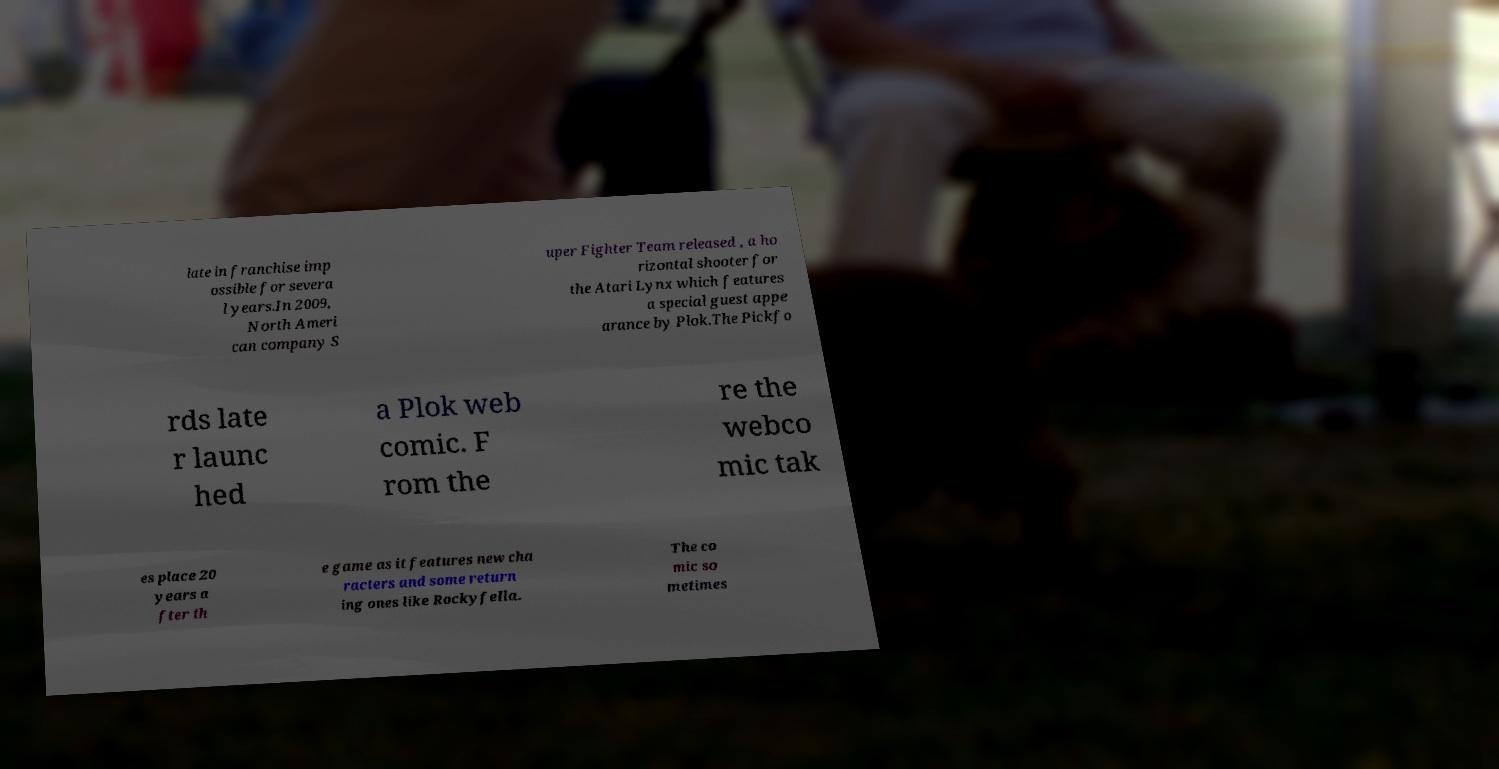There's text embedded in this image that I need extracted. Can you transcribe it verbatim? late in franchise imp ossible for severa l years.In 2009, North Ameri can company S uper Fighter Team released , a ho rizontal shooter for the Atari Lynx which features a special guest appe arance by Plok.The Pickfo rds late r launc hed a Plok web comic. F rom the re the webco mic tak es place 20 years a fter th e game as it features new cha racters and some return ing ones like Rockyfella. The co mic so metimes 